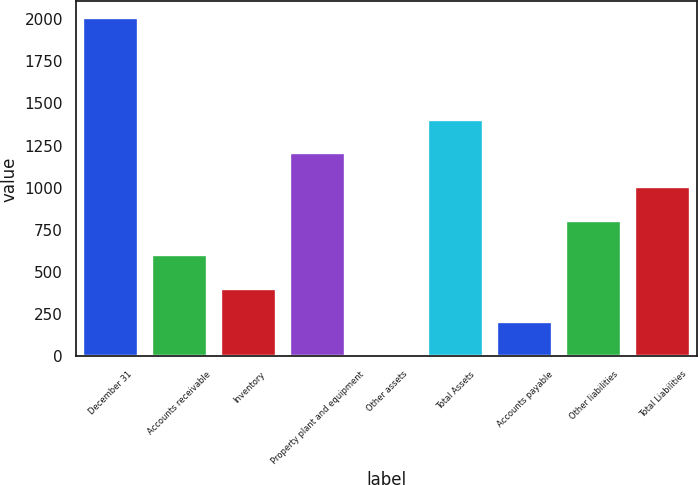<chart> <loc_0><loc_0><loc_500><loc_500><bar_chart><fcel>December 31<fcel>Accounts receivable<fcel>Inventory<fcel>Property plant and equipment<fcel>Other assets<fcel>Total Assets<fcel>Accounts payable<fcel>Other liabilities<fcel>Total Liabilities<nl><fcel>2005<fcel>602.9<fcel>402.6<fcel>1203.8<fcel>2<fcel>1404.1<fcel>202.3<fcel>803.2<fcel>1003.5<nl></chart> 